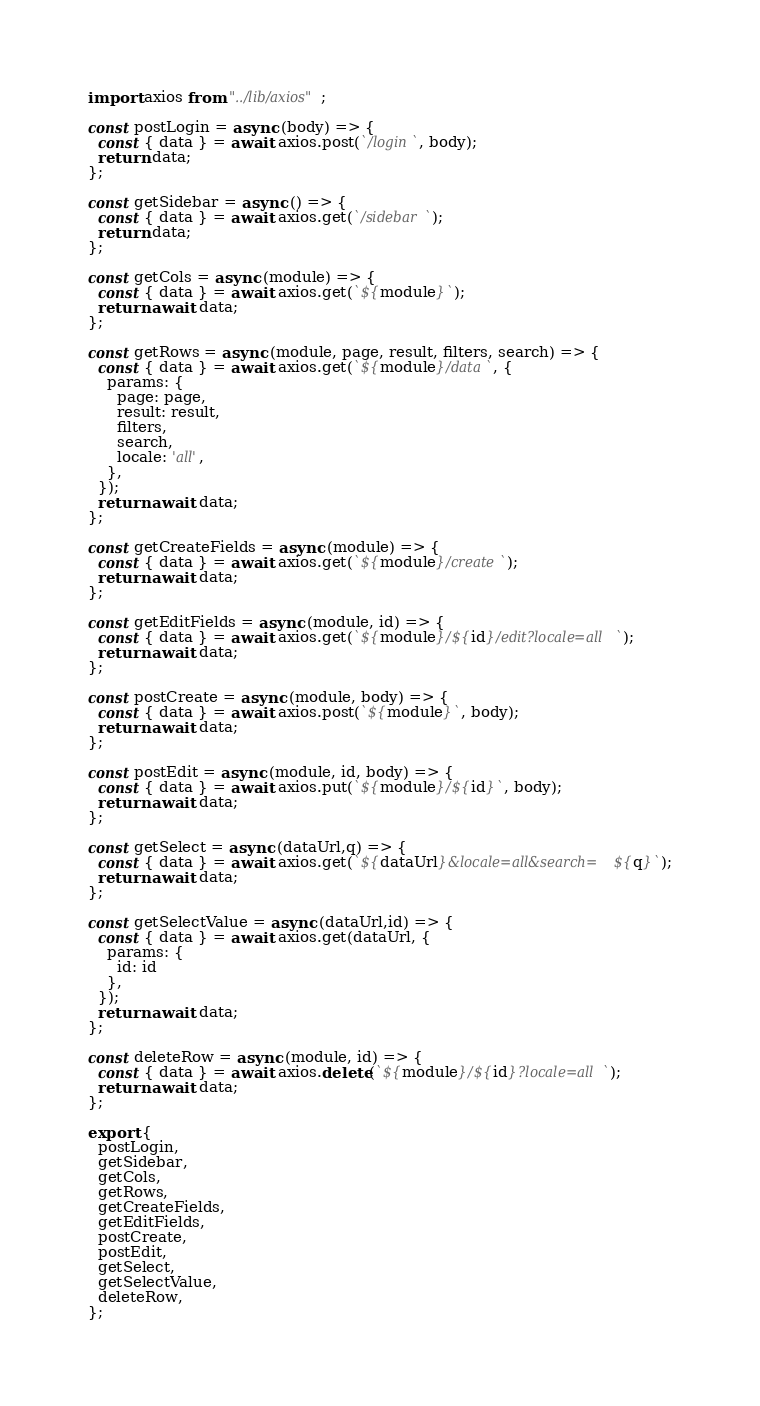<code> <loc_0><loc_0><loc_500><loc_500><_JavaScript_>import axios from "../lib/axios";

const postLogin = async (body) => {
  const { data } = await axios.post(`/login`, body);
  return data;
};

const getSidebar = async () => {
  const { data } = await axios.get(`/sidebar`);
  return data;
};

const getCols = async (module) => {
  const { data } = await axios.get(`${module}`);
  return await data;
};

const getRows = async (module, page, result, filters, search) => {
  const { data } = await axios.get(`${module}/data`, {
    params: {
      page: page,
      result: result,
      filters,
      search,
      locale: 'all',
    },
  });
  return await data;
};

const getCreateFields = async (module) => {
  const { data } = await axios.get(`${module}/create`);
  return await data;
};

const getEditFields = async (module, id) => {
  const { data } = await axios.get(`${module}/${id}/edit?locale=all`);
  return await data;
};

const postCreate = async (module, body) => {
  const { data } = await axios.post(`${module}`, body);
  return await data;
};

const postEdit = async (module, id, body) => {
  const { data } = await axios.put(`${module}/${id}`, body);
  return await data;
};

const getSelect = async (dataUrl,q) => {
  const { data } = await axios.get(`${dataUrl}&locale=all&search=${q}`);
  return await data;
};

const getSelectValue = async (dataUrl,id) => {
  const { data } = await axios.get(dataUrl, {
    params: {
      id: id
    },  
  });
  return await data;
};

const deleteRow = async (module, id) => {
  const { data } = await axios.delete(`${module}/${id}?locale=all`);
  return await data;
};

export {
  postLogin,
  getSidebar,
  getCols,
  getRows,
  getCreateFields,
  getEditFields,
  postCreate,
  postEdit,
  getSelect,
  getSelectValue,
  deleteRow,
};
</code> 